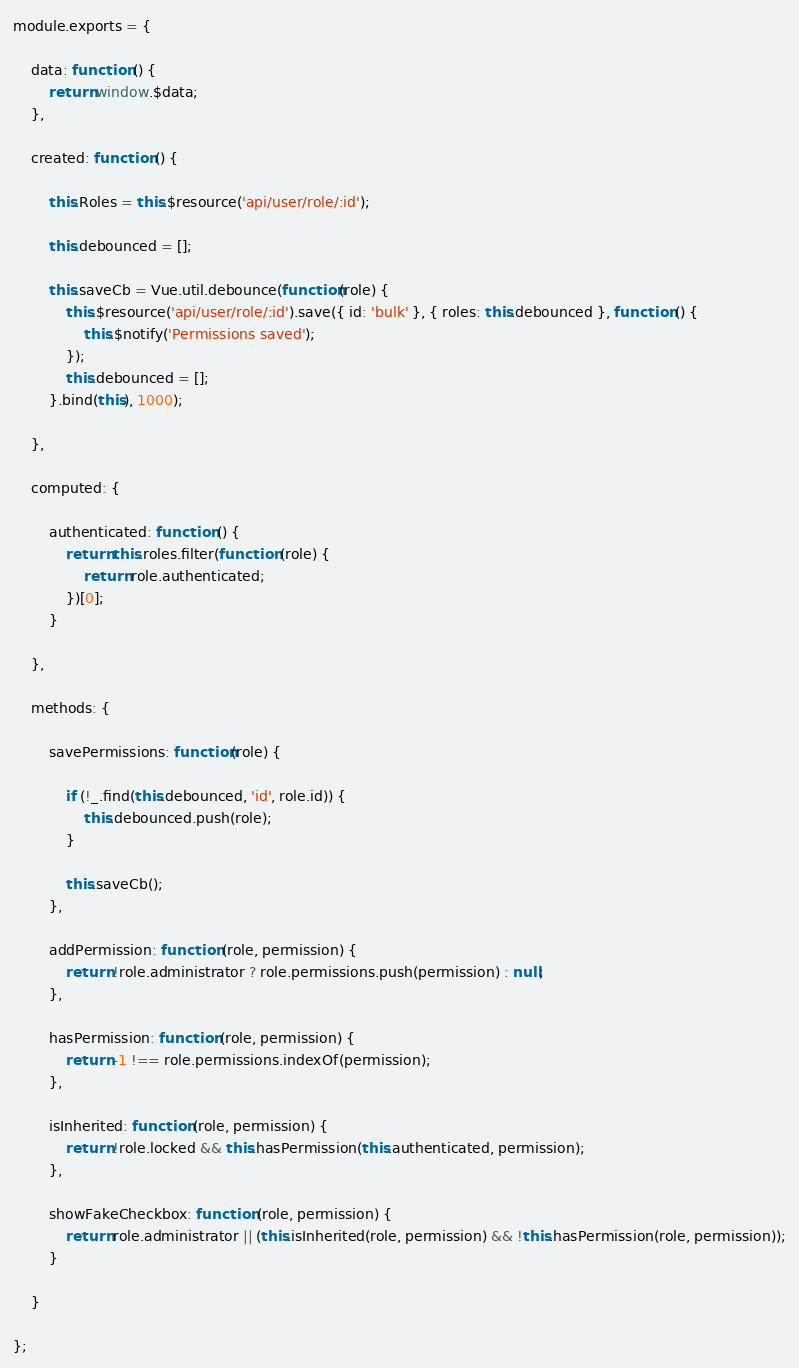Convert code to text. <code><loc_0><loc_0><loc_500><loc_500><_JavaScript_>module.exports = {

    data: function () {
        return window.$data;
    },

    created: function () {

        this.Roles = this.$resource('api/user/role/:id');

        this.debounced = [];

        this.saveCb = Vue.util.debounce(function(role) {
            this.$resource('api/user/role/:id').save({ id: 'bulk' }, { roles: this.debounced }, function () {
                this.$notify('Permissions saved');
            });
            this.debounced = [];
        }.bind(this), 1000);

    },

    computed: {

        authenticated: function () {
            return this.roles.filter(function (role) {
                return role.authenticated;
            })[0];
        }

    },

    methods: {

        savePermissions: function(role) {

            if (!_.find(this.debounced, 'id', role.id)) {
                this.debounced.push(role);
            }

            this.saveCb();
        },

        addPermission: function (role, permission) {
            return !role.administrator ? role.permissions.push(permission) : null;
        },

        hasPermission: function (role, permission) {
            return -1 !== role.permissions.indexOf(permission);
        },

        isInherited: function (role, permission) {
            return !role.locked && this.hasPermission(this.authenticated, permission);
        },

        showFakeCheckbox: function (role, permission) {
            return role.administrator || (this.isInherited(role, permission) && !this.hasPermission(role, permission));
        }

    }

};
</code> 